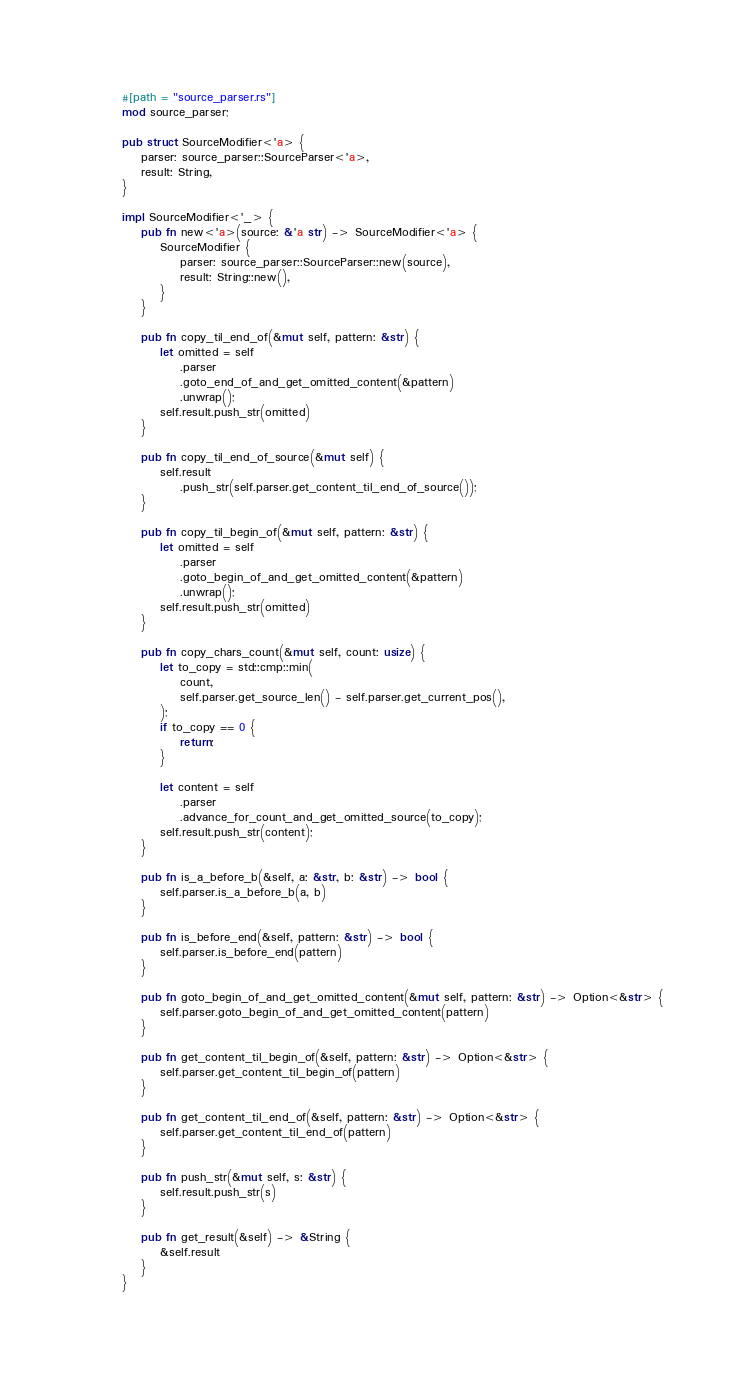Convert code to text. <code><loc_0><loc_0><loc_500><loc_500><_Rust_>#[path = "source_parser.rs"]
mod source_parser;

pub struct SourceModifier<'a> {
    parser: source_parser::SourceParser<'a>,
    result: String,
}

impl SourceModifier<'_> {
    pub fn new<'a>(source: &'a str) -> SourceModifier<'a> {
        SourceModifier {
            parser: source_parser::SourceParser::new(source),
            result: String::new(),
        }
    }

    pub fn copy_til_end_of(&mut self, pattern: &str) {
        let omitted = self
            .parser
            .goto_end_of_and_get_omitted_content(&pattern)
            .unwrap();
        self.result.push_str(omitted)
    }

    pub fn copy_til_end_of_source(&mut self) {
        self.result
            .push_str(self.parser.get_content_til_end_of_source());
    }

    pub fn copy_til_begin_of(&mut self, pattern: &str) {
        let omitted = self
            .parser
            .goto_begin_of_and_get_omitted_content(&pattern)
            .unwrap();
        self.result.push_str(omitted)
    }

    pub fn copy_chars_count(&mut self, count: usize) {
        let to_copy = std::cmp::min(
            count,
            self.parser.get_source_len() - self.parser.get_current_pos(),
        );
        if to_copy == 0 {
            return;
        }

        let content = self
            .parser
            .advance_for_count_and_get_omitted_source(to_copy);
        self.result.push_str(content);
    }

    pub fn is_a_before_b(&self, a: &str, b: &str) -> bool {
        self.parser.is_a_before_b(a, b)
    }

    pub fn is_before_end(&self, pattern: &str) -> bool {
        self.parser.is_before_end(pattern)
    }

    pub fn goto_begin_of_and_get_omitted_content(&mut self, pattern: &str) -> Option<&str> {
        self.parser.goto_begin_of_and_get_omitted_content(pattern)
    }

    pub fn get_content_til_begin_of(&self, pattern: &str) -> Option<&str> {
        self.parser.get_content_til_begin_of(pattern)
    }

    pub fn get_content_til_end_of(&self, pattern: &str) -> Option<&str> {
        self.parser.get_content_til_end_of(pattern)
    }

    pub fn push_str(&mut self, s: &str) {
        self.result.push_str(s)
    }

    pub fn get_result(&self) -> &String {
        &self.result
    }
}
</code> 